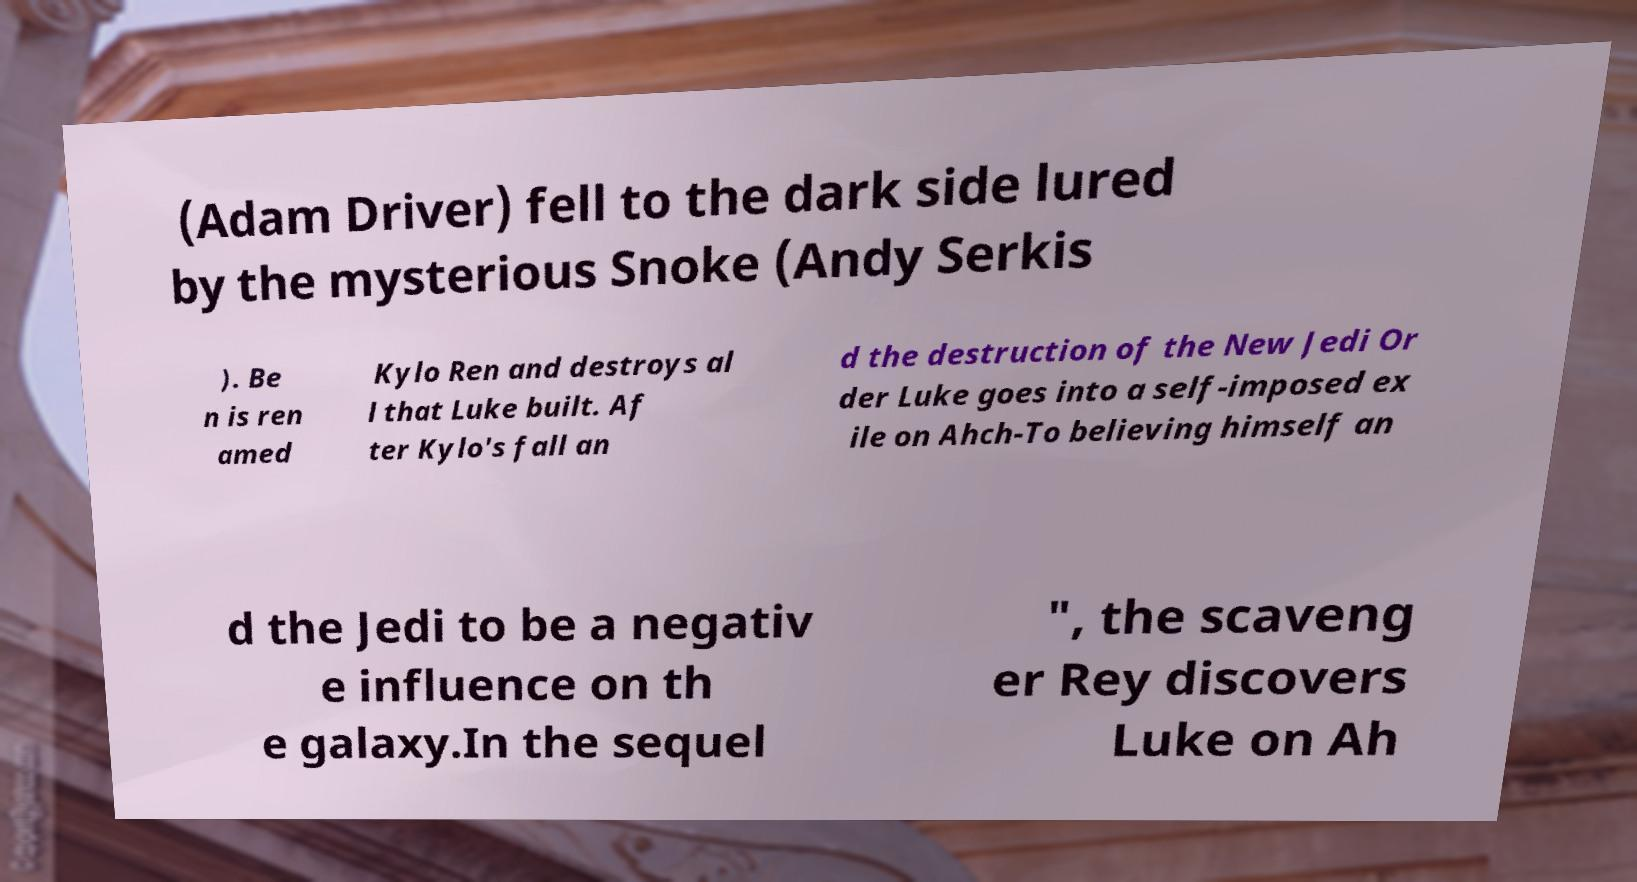For documentation purposes, I need the text within this image transcribed. Could you provide that? (Adam Driver) fell to the dark side lured by the mysterious Snoke (Andy Serkis ). Be n is ren amed Kylo Ren and destroys al l that Luke built. Af ter Kylo's fall an d the destruction of the New Jedi Or der Luke goes into a self-imposed ex ile on Ahch-To believing himself an d the Jedi to be a negativ e influence on th e galaxy.In the sequel ", the scaveng er Rey discovers Luke on Ah 